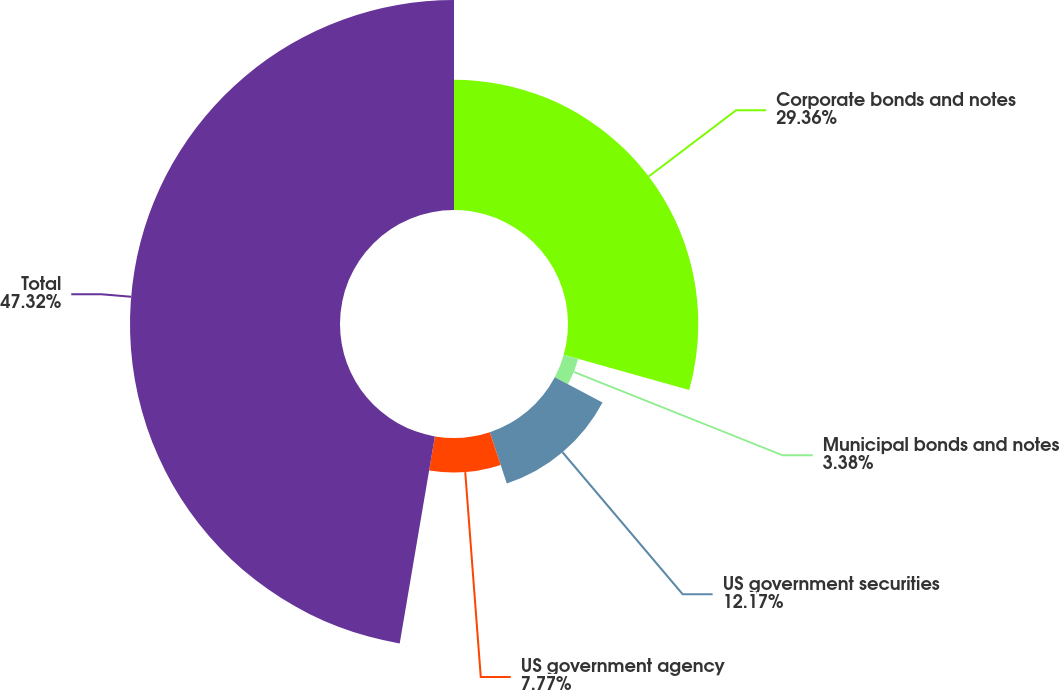<chart> <loc_0><loc_0><loc_500><loc_500><pie_chart><fcel>Corporate bonds and notes<fcel>Municipal bonds and notes<fcel>US government securities<fcel>US government agency<fcel>Total<nl><fcel>29.36%<fcel>3.38%<fcel>12.17%<fcel>7.77%<fcel>47.32%<nl></chart> 